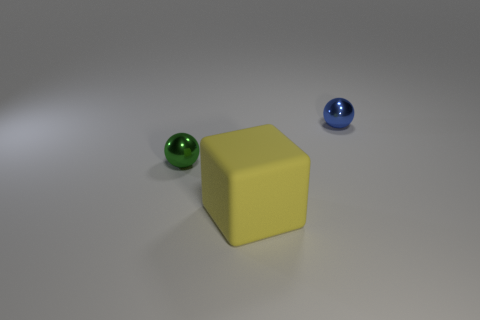Subtract all yellow balls. Subtract all brown cubes. How many balls are left? 2 Add 1 large matte cubes. How many objects exist? 4 Subtract all blocks. How many objects are left? 2 Subtract 0 brown cubes. How many objects are left? 3 Subtract all big rubber objects. Subtract all yellow cubes. How many objects are left? 1 Add 1 tiny blue objects. How many tiny blue objects are left? 2 Add 2 tiny metal things. How many tiny metal things exist? 4 